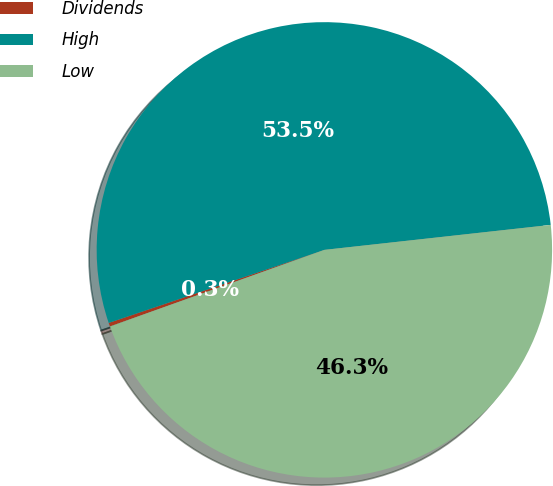<chart> <loc_0><loc_0><loc_500><loc_500><pie_chart><fcel>Dividends<fcel>High<fcel>Low<nl><fcel>0.26%<fcel>53.45%<fcel>46.29%<nl></chart> 